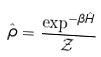Convert formula to latex. <formula><loc_0><loc_0><loc_500><loc_500>\hat { \rho } = \frac { \exp ^ { - \beta \hat { H } } } { \mathcal { Z } }</formula> 